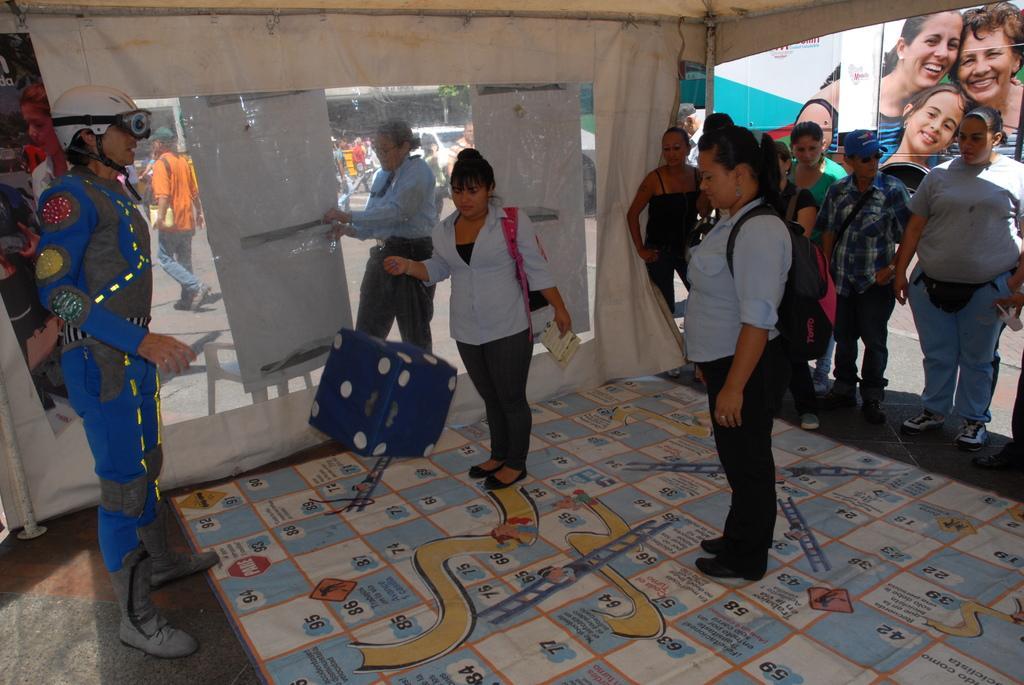How would you summarize this image in a sentence or two? In this picture, we see two women who are wearing blue shirts are playing snake and ladder game. In front of them, we see a blue color dice. The man in blue dress who is wearing a white helmet is guiding them. Behind them, we see people standing. Behind them, we see a banner of three people smiling. In the background, we see people walking on the road. We even see a white car moving on the road. 